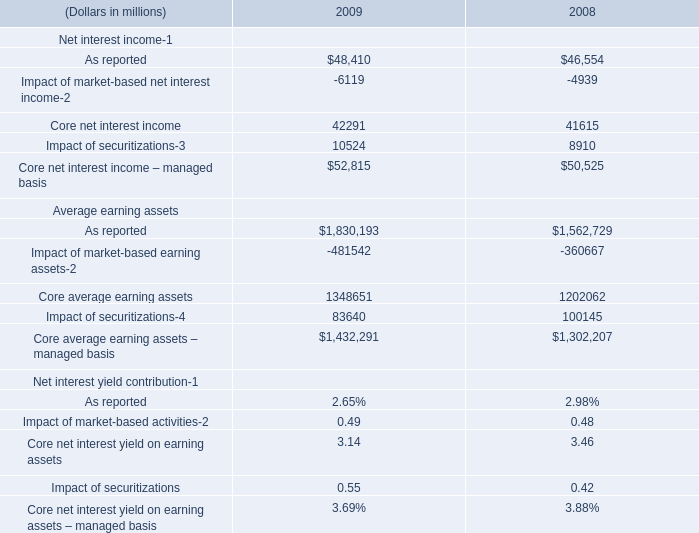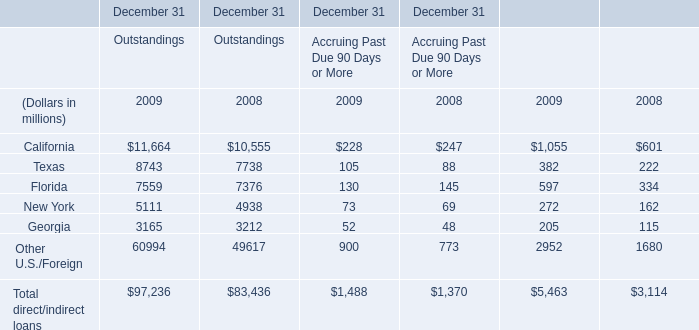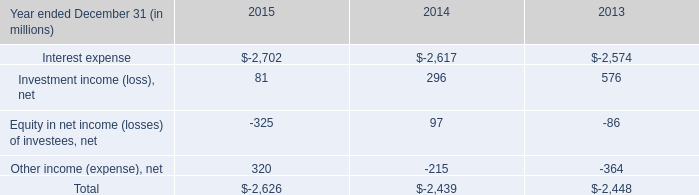What is the total amount of California of December 31 2009, As reported Average earning assets of 2008, and Impact of securitizations Average earning assets of 2009 ? 
Computations: ((1055.0 + 1562729.0) + 83640.0)
Answer: 1647424.0. 